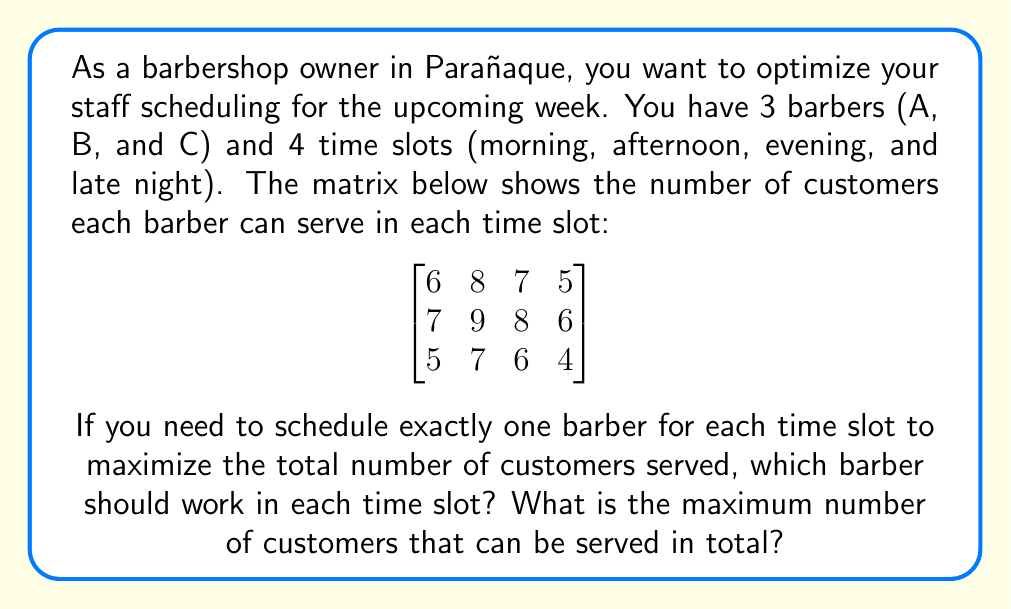Solve this math problem. Let's approach this step-by-step:

1) First, we need to find the maximum value in each column of the matrix. This will give us the barber who can serve the most customers in each time slot.

   Morning (1st column): max(6, 7, 5) = 7 (Barber B)
   Afternoon (2nd column): max(8, 9, 7) = 9 (Barber B)
   Evening (3rd column): max(7, 8, 6) = 8 (Barber B)
   Late night (4th column): max(5, 6, 4) = 6 (Barber B)

2) However, we can't schedule Barber B for all shifts as we need to use each barber exactly once.

3) To maximize the total, we should assign Barber B to the time slot where they have the biggest advantage over the next best barber. Let's calculate the differences:

   Morning: 7 - 6 = 1
   Afternoon: 9 - 8 = 1
   Evening: 8 - 7 = 1
   Late night: 6 - 5 = 1

4) Since all differences are equal, we can assign Barber B to any slot. Let's choose the afternoon slot as it has the highest absolute number (9).

5) Now, for the remaining slots, we compare Barbers A and C:

   Morning: A (6) > C (5)
   Evening: A (7) > C (6)
   Late night: A (5) > C (4)

6) Therefore, we assign Barber A to the evening slot (highest remaining number), and Barber C to the morning slot.

7) The final assignment is:
   Morning: Barber C (5 customers)
   Afternoon: Barber B (9 customers)
   Evening: Barber A (7 customers)
   Late night: Barber A (5 customers)

8) The total number of customers served is: 5 + 9 + 7 + 5 = 26
Answer: Optimal schedule: C, B, A, A. Maximum customers: 26. 